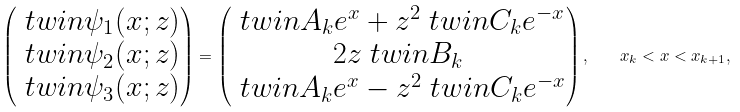<formula> <loc_0><loc_0><loc_500><loc_500>\begin{pmatrix} \ t w i n \psi _ { 1 } ( x ; z ) \\ \ t w i n \psi _ { 2 } ( x ; z ) \\ \ t w i n \psi _ { 3 } ( x ; z ) \end{pmatrix} = \begin{pmatrix} \ t w i n A _ { k } e ^ { x } + z ^ { 2 } \ t w i n C _ { k } e ^ { - x } \\ 2 z \ t w i n B _ { k } \\ \ t w i n A _ { k } e ^ { x } - z ^ { 2 } \ t w i n C _ { k } e ^ { - x } \end{pmatrix} , \quad x _ { k } < x < x _ { k + 1 } ,</formula> 